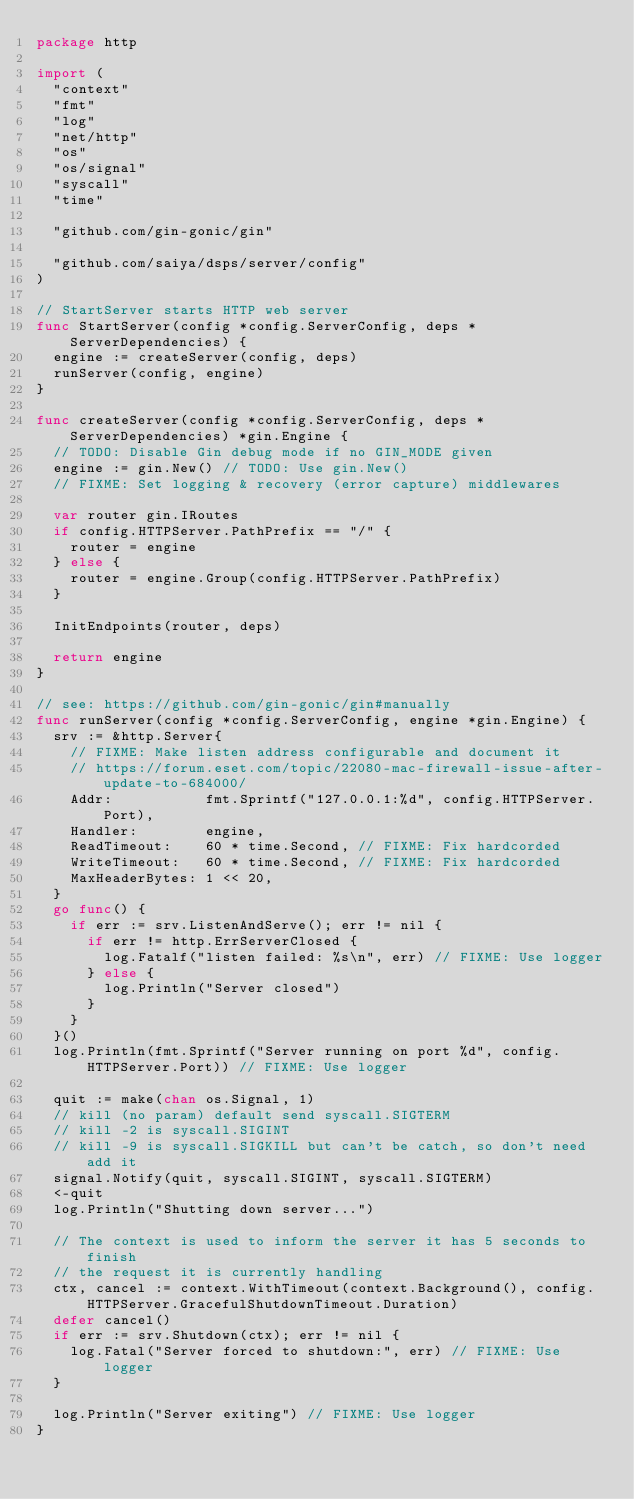Convert code to text. <code><loc_0><loc_0><loc_500><loc_500><_Go_>package http

import (
	"context"
	"fmt"
	"log"
	"net/http"
	"os"
	"os/signal"
	"syscall"
	"time"

	"github.com/gin-gonic/gin"

	"github.com/saiya/dsps/server/config"
)

// StartServer starts HTTP web server
func StartServer(config *config.ServerConfig, deps *ServerDependencies) {
	engine := createServer(config, deps)
	runServer(config, engine)
}

func createServer(config *config.ServerConfig, deps *ServerDependencies) *gin.Engine {
	// TODO: Disable Gin debug mode if no GIN_MODE given
	engine := gin.New() // TODO: Use gin.New()
	// FIXME: Set logging & recovery (error capture) middlewares

	var router gin.IRoutes
	if config.HTTPServer.PathPrefix == "/" {
		router = engine
	} else {
		router = engine.Group(config.HTTPServer.PathPrefix)
	}

	InitEndpoints(router, deps)

	return engine
}

// see: https://github.com/gin-gonic/gin#manually
func runServer(config *config.ServerConfig, engine *gin.Engine) {
	srv := &http.Server{
		// FIXME: Make listen address configurable and document it
		// https://forum.eset.com/topic/22080-mac-firewall-issue-after-update-to-684000/
		Addr:           fmt.Sprintf("127.0.0.1:%d", config.HTTPServer.Port),
		Handler:        engine,
		ReadTimeout:    60 * time.Second, // FIXME: Fix hardcorded
		WriteTimeout:   60 * time.Second, // FIXME: Fix hardcorded
		MaxHeaderBytes: 1 << 20,
	}
	go func() {
		if err := srv.ListenAndServe(); err != nil {
			if err != http.ErrServerClosed {
				log.Fatalf("listen failed: %s\n", err) // FIXME: Use logger
			} else {
				log.Println("Server closed")
			}
		}
	}()
	log.Println(fmt.Sprintf("Server running on port %d", config.HTTPServer.Port)) // FIXME: Use logger

	quit := make(chan os.Signal, 1)
	// kill (no param) default send syscall.SIGTERM
	// kill -2 is syscall.SIGINT
	// kill -9 is syscall.SIGKILL but can't be catch, so don't need add it
	signal.Notify(quit, syscall.SIGINT, syscall.SIGTERM)
	<-quit
	log.Println("Shutting down server...")

	// The context is used to inform the server it has 5 seconds to finish
	// the request it is currently handling
	ctx, cancel := context.WithTimeout(context.Background(), config.HTTPServer.GracefulShutdownTimeout.Duration)
	defer cancel()
	if err := srv.Shutdown(ctx); err != nil {
		log.Fatal("Server forced to shutdown:", err) // FIXME: Use logger
	}

	log.Println("Server exiting") // FIXME: Use logger
}
</code> 